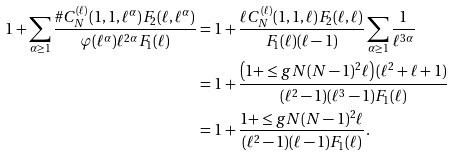Convert formula to latex. <formula><loc_0><loc_0><loc_500><loc_500>1 + \sum _ { \alpha \geq 1 } \frac { \# C _ { N } ^ { ( \ell ) } ( 1 , 1 , \ell ^ { \alpha } ) F _ { 2 } ( \ell , \ell ^ { \alpha } ) } { \varphi ( \ell ^ { \alpha } ) \ell ^ { 2 \alpha } F _ { 1 } ( \ell ) } & = 1 + \frac { \ell C _ { N } ^ { ( \ell ) } ( 1 , 1 , \ell ) F _ { 2 } ( \ell , \ell ) } { F _ { 1 } ( \ell ) ( \ell - 1 ) } \sum _ { \alpha \geq 1 } \frac { 1 } { \ell ^ { 3 \alpha } } \\ & = 1 + \frac { \left ( 1 + \leq g { N ( N - 1 ) ^ { 2 } } { \ell } \right ) ( \ell ^ { 2 } + \ell + 1 ) } { ( \ell ^ { 2 } - 1 ) ( \ell ^ { 3 } - 1 ) F _ { 1 } ( \ell ) } \\ & = 1 + \frac { 1 + \leq g { N ( N - 1 ) ^ { 2 } } { \ell } } { ( \ell ^ { 2 } - 1 ) ( \ell - 1 ) F _ { 1 } ( \ell ) } .</formula> 